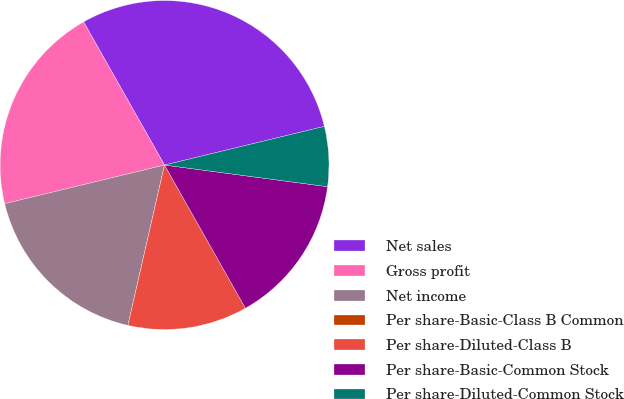Convert chart. <chart><loc_0><loc_0><loc_500><loc_500><pie_chart><fcel>Net sales<fcel>Gross profit<fcel>Net income<fcel>Per share-Basic-Class B Common<fcel>Per share-Diluted-Class B<fcel>Per share-Basic-Common Stock<fcel>Per share-Diluted-Common Stock<nl><fcel>29.41%<fcel>20.59%<fcel>17.65%<fcel>0.0%<fcel>11.76%<fcel>14.71%<fcel>5.88%<nl></chart> 